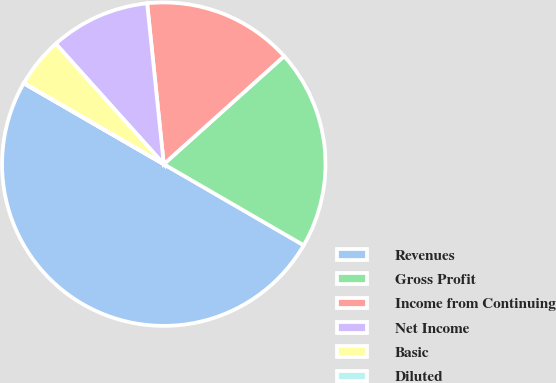Convert chart. <chart><loc_0><loc_0><loc_500><loc_500><pie_chart><fcel>Revenues<fcel>Gross Profit<fcel>Income from Continuing<fcel>Net Income<fcel>Basic<fcel>Diluted<nl><fcel>49.98%<fcel>20.0%<fcel>15.0%<fcel>10.0%<fcel>5.01%<fcel>0.01%<nl></chart> 